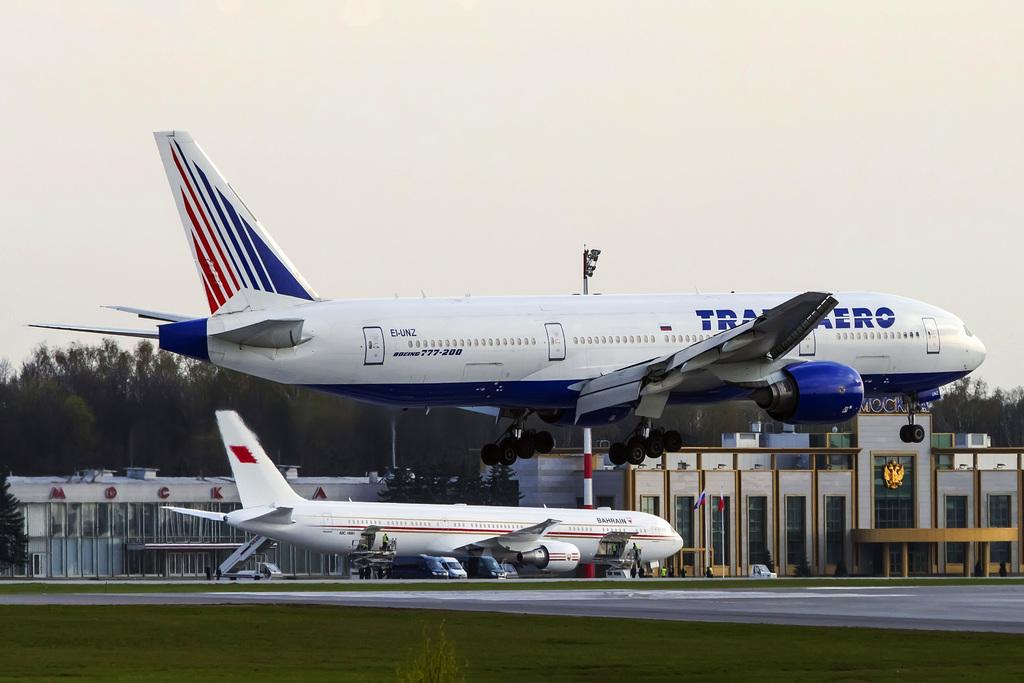What does it say on the airplane?
Provide a short and direct response. Transaero. What is the number of the plane?
Your answer should be compact. 777-200. 